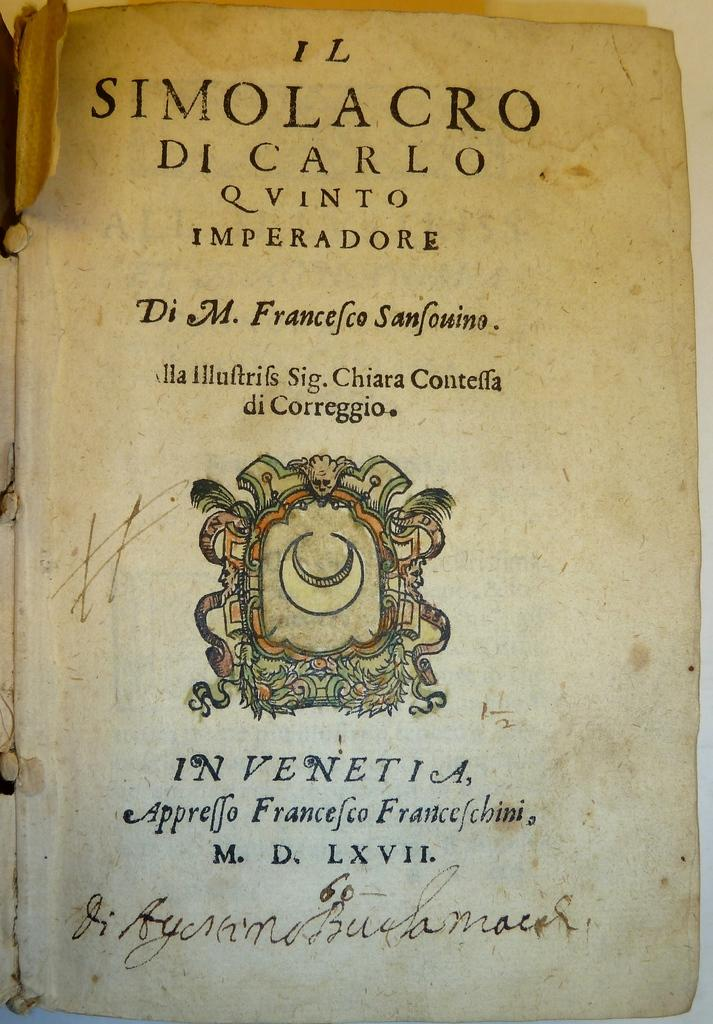<image>
Provide a brief description of the given image. An old book by Di M. Franceio Sanfouino is open to the cover page 